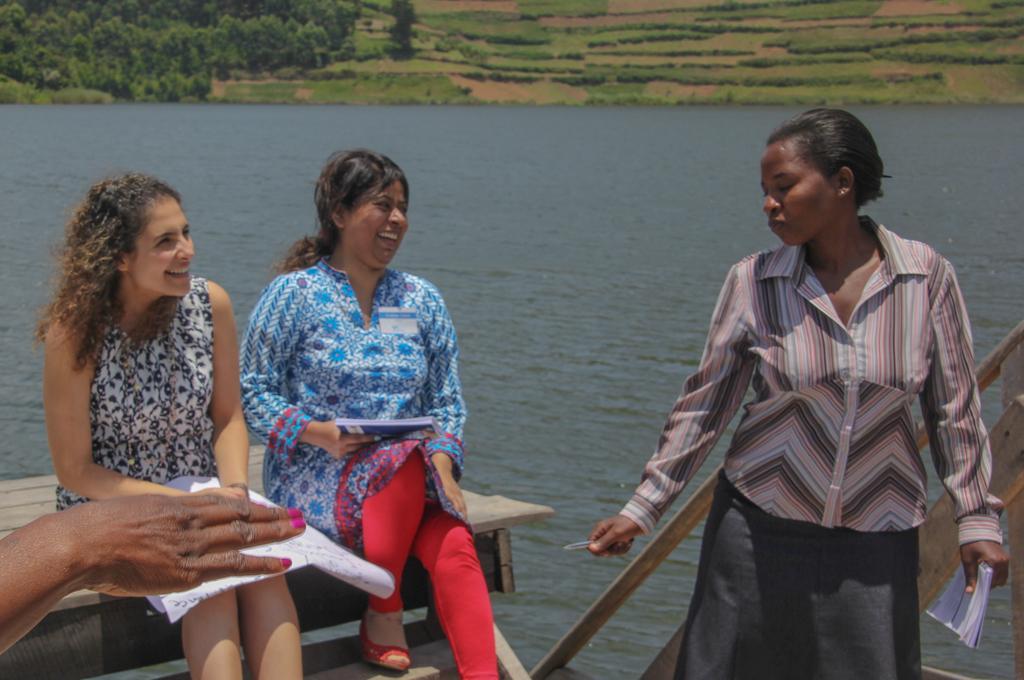Please provide a concise description of this image. On the left side, there are two women smiling and sitting on a wooden surface and there is a hand of a person. On the right side, there is another woman holding a book with a hand, holding a knife with the other hand, smiling and standing. In the background, there is water, there are trees, plants and grass on the ground. 